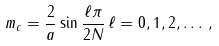Convert formula to latex. <formula><loc_0><loc_0><loc_500><loc_500>m _ { c } = \frac { 2 } { a } \sin \frac { \ell \pi } { 2 N } \, \ell = 0 , 1 , 2 , \dots \, ,</formula> 